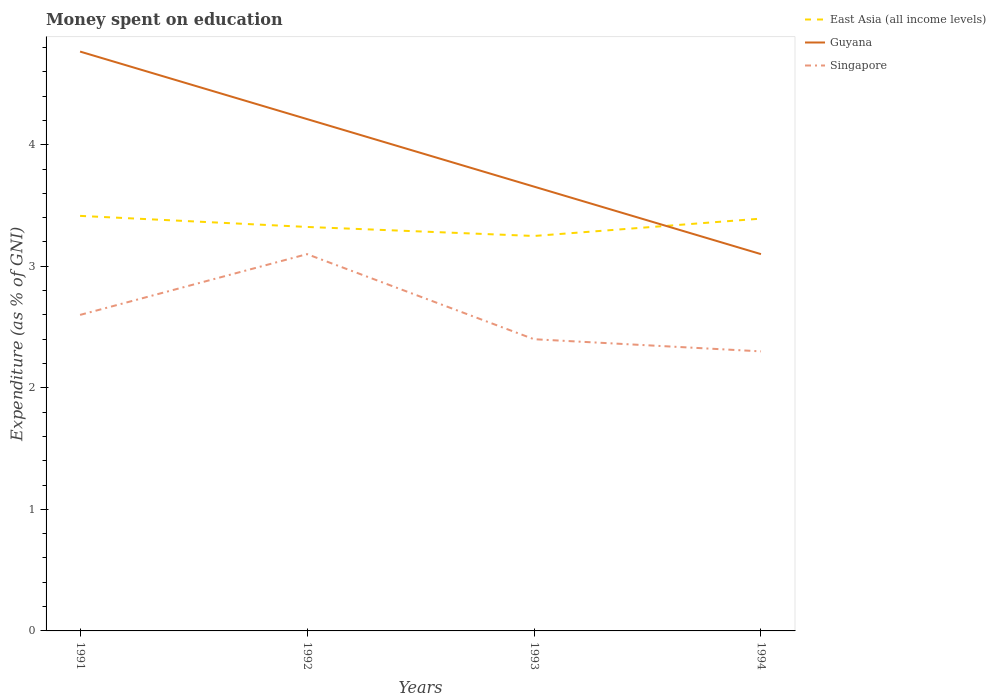Across all years, what is the maximum amount of money spent on education in East Asia (all income levels)?
Ensure brevity in your answer.  3.25. What is the total amount of money spent on education in Guyana in the graph?
Keep it short and to the point. 0.56. What is the difference between the highest and the second highest amount of money spent on education in East Asia (all income levels)?
Your answer should be very brief. 0.17. What is the difference between the highest and the lowest amount of money spent on education in Singapore?
Your answer should be compact. 2. How many lines are there?
Offer a very short reply. 3. How many years are there in the graph?
Give a very brief answer. 4. What is the difference between two consecutive major ticks on the Y-axis?
Provide a succinct answer. 1. Are the values on the major ticks of Y-axis written in scientific E-notation?
Keep it short and to the point. No. Does the graph contain any zero values?
Offer a very short reply. No. Does the graph contain grids?
Your answer should be compact. No. Where does the legend appear in the graph?
Provide a succinct answer. Top right. How many legend labels are there?
Your answer should be compact. 3. What is the title of the graph?
Provide a short and direct response. Money spent on education. Does "Afghanistan" appear as one of the legend labels in the graph?
Offer a very short reply. No. What is the label or title of the Y-axis?
Your response must be concise. Expenditure (as % of GNI). What is the Expenditure (as % of GNI) in East Asia (all income levels) in 1991?
Offer a terse response. 3.41. What is the Expenditure (as % of GNI) of Guyana in 1991?
Your answer should be very brief. 4.77. What is the Expenditure (as % of GNI) of East Asia (all income levels) in 1992?
Provide a succinct answer. 3.32. What is the Expenditure (as % of GNI) of Guyana in 1992?
Keep it short and to the point. 4.21. What is the Expenditure (as % of GNI) of Singapore in 1992?
Offer a very short reply. 3.1. What is the Expenditure (as % of GNI) in East Asia (all income levels) in 1993?
Your answer should be compact. 3.25. What is the Expenditure (as % of GNI) of Guyana in 1993?
Keep it short and to the point. 3.66. What is the Expenditure (as % of GNI) of East Asia (all income levels) in 1994?
Your response must be concise. 3.39. What is the Expenditure (as % of GNI) in Singapore in 1994?
Offer a terse response. 2.3. Across all years, what is the maximum Expenditure (as % of GNI) in East Asia (all income levels)?
Keep it short and to the point. 3.41. Across all years, what is the maximum Expenditure (as % of GNI) of Guyana?
Your response must be concise. 4.77. Across all years, what is the minimum Expenditure (as % of GNI) in East Asia (all income levels)?
Ensure brevity in your answer.  3.25. Across all years, what is the minimum Expenditure (as % of GNI) in Guyana?
Keep it short and to the point. 3.1. Across all years, what is the minimum Expenditure (as % of GNI) of Singapore?
Keep it short and to the point. 2.3. What is the total Expenditure (as % of GNI) in East Asia (all income levels) in the graph?
Provide a short and direct response. 13.38. What is the total Expenditure (as % of GNI) of Guyana in the graph?
Keep it short and to the point. 15.73. What is the difference between the Expenditure (as % of GNI) of East Asia (all income levels) in 1991 and that in 1992?
Your answer should be very brief. 0.09. What is the difference between the Expenditure (as % of GNI) in Guyana in 1991 and that in 1992?
Your answer should be compact. 0.56. What is the difference between the Expenditure (as % of GNI) in East Asia (all income levels) in 1991 and that in 1993?
Offer a very short reply. 0.17. What is the difference between the Expenditure (as % of GNI) of Guyana in 1991 and that in 1993?
Provide a succinct answer. 1.11. What is the difference between the Expenditure (as % of GNI) in Singapore in 1991 and that in 1993?
Provide a succinct answer. 0.2. What is the difference between the Expenditure (as % of GNI) in East Asia (all income levels) in 1991 and that in 1994?
Ensure brevity in your answer.  0.02. What is the difference between the Expenditure (as % of GNI) in East Asia (all income levels) in 1992 and that in 1993?
Ensure brevity in your answer.  0.07. What is the difference between the Expenditure (as % of GNI) in Guyana in 1992 and that in 1993?
Your answer should be very brief. 0.56. What is the difference between the Expenditure (as % of GNI) of Singapore in 1992 and that in 1993?
Offer a very short reply. 0.7. What is the difference between the Expenditure (as % of GNI) in East Asia (all income levels) in 1992 and that in 1994?
Offer a very short reply. -0.07. What is the difference between the Expenditure (as % of GNI) in East Asia (all income levels) in 1993 and that in 1994?
Your answer should be very brief. -0.14. What is the difference between the Expenditure (as % of GNI) in Guyana in 1993 and that in 1994?
Provide a short and direct response. 0.56. What is the difference between the Expenditure (as % of GNI) in Singapore in 1993 and that in 1994?
Offer a very short reply. 0.1. What is the difference between the Expenditure (as % of GNI) in East Asia (all income levels) in 1991 and the Expenditure (as % of GNI) in Guyana in 1992?
Provide a short and direct response. -0.8. What is the difference between the Expenditure (as % of GNI) of East Asia (all income levels) in 1991 and the Expenditure (as % of GNI) of Singapore in 1992?
Your response must be concise. 0.31. What is the difference between the Expenditure (as % of GNI) in East Asia (all income levels) in 1991 and the Expenditure (as % of GNI) in Guyana in 1993?
Ensure brevity in your answer.  -0.24. What is the difference between the Expenditure (as % of GNI) of East Asia (all income levels) in 1991 and the Expenditure (as % of GNI) of Singapore in 1993?
Keep it short and to the point. 1.01. What is the difference between the Expenditure (as % of GNI) in Guyana in 1991 and the Expenditure (as % of GNI) in Singapore in 1993?
Provide a succinct answer. 2.37. What is the difference between the Expenditure (as % of GNI) in East Asia (all income levels) in 1991 and the Expenditure (as % of GNI) in Guyana in 1994?
Offer a very short reply. 0.31. What is the difference between the Expenditure (as % of GNI) of East Asia (all income levels) in 1991 and the Expenditure (as % of GNI) of Singapore in 1994?
Keep it short and to the point. 1.11. What is the difference between the Expenditure (as % of GNI) of Guyana in 1991 and the Expenditure (as % of GNI) of Singapore in 1994?
Offer a very short reply. 2.47. What is the difference between the Expenditure (as % of GNI) of East Asia (all income levels) in 1992 and the Expenditure (as % of GNI) of Guyana in 1993?
Give a very brief answer. -0.33. What is the difference between the Expenditure (as % of GNI) of East Asia (all income levels) in 1992 and the Expenditure (as % of GNI) of Singapore in 1993?
Your answer should be compact. 0.92. What is the difference between the Expenditure (as % of GNI) in Guyana in 1992 and the Expenditure (as % of GNI) in Singapore in 1993?
Keep it short and to the point. 1.81. What is the difference between the Expenditure (as % of GNI) of East Asia (all income levels) in 1992 and the Expenditure (as % of GNI) of Guyana in 1994?
Offer a terse response. 0.22. What is the difference between the Expenditure (as % of GNI) of East Asia (all income levels) in 1992 and the Expenditure (as % of GNI) of Singapore in 1994?
Ensure brevity in your answer.  1.02. What is the difference between the Expenditure (as % of GNI) of Guyana in 1992 and the Expenditure (as % of GNI) of Singapore in 1994?
Your response must be concise. 1.91. What is the difference between the Expenditure (as % of GNI) in East Asia (all income levels) in 1993 and the Expenditure (as % of GNI) in Guyana in 1994?
Your answer should be very brief. 0.15. What is the difference between the Expenditure (as % of GNI) in East Asia (all income levels) in 1993 and the Expenditure (as % of GNI) in Singapore in 1994?
Your response must be concise. 0.95. What is the difference between the Expenditure (as % of GNI) of Guyana in 1993 and the Expenditure (as % of GNI) of Singapore in 1994?
Your answer should be compact. 1.36. What is the average Expenditure (as % of GNI) in East Asia (all income levels) per year?
Your response must be concise. 3.35. What is the average Expenditure (as % of GNI) of Guyana per year?
Give a very brief answer. 3.93. What is the average Expenditure (as % of GNI) in Singapore per year?
Keep it short and to the point. 2.6. In the year 1991, what is the difference between the Expenditure (as % of GNI) in East Asia (all income levels) and Expenditure (as % of GNI) in Guyana?
Ensure brevity in your answer.  -1.35. In the year 1991, what is the difference between the Expenditure (as % of GNI) of East Asia (all income levels) and Expenditure (as % of GNI) of Singapore?
Your answer should be compact. 0.81. In the year 1991, what is the difference between the Expenditure (as % of GNI) in Guyana and Expenditure (as % of GNI) in Singapore?
Your answer should be very brief. 2.17. In the year 1992, what is the difference between the Expenditure (as % of GNI) of East Asia (all income levels) and Expenditure (as % of GNI) of Guyana?
Ensure brevity in your answer.  -0.89. In the year 1992, what is the difference between the Expenditure (as % of GNI) of East Asia (all income levels) and Expenditure (as % of GNI) of Singapore?
Offer a very short reply. 0.22. In the year 1992, what is the difference between the Expenditure (as % of GNI) of Guyana and Expenditure (as % of GNI) of Singapore?
Make the answer very short. 1.11. In the year 1993, what is the difference between the Expenditure (as % of GNI) in East Asia (all income levels) and Expenditure (as % of GNI) in Guyana?
Your answer should be compact. -0.41. In the year 1993, what is the difference between the Expenditure (as % of GNI) in East Asia (all income levels) and Expenditure (as % of GNI) in Singapore?
Your response must be concise. 0.85. In the year 1993, what is the difference between the Expenditure (as % of GNI) of Guyana and Expenditure (as % of GNI) of Singapore?
Ensure brevity in your answer.  1.26. In the year 1994, what is the difference between the Expenditure (as % of GNI) of East Asia (all income levels) and Expenditure (as % of GNI) of Guyana?
Offer a terse response. 0.29. In the year 1994, what is the difference between the Expenditure (as % of GNI) of East Asia (all income levels) and Expenditure (as % of GNI) of Singapore?
Offer a very short reply. 1.09. In the year 1994, what is the difference between the Expenditure (as % of GNI) of Guyana and Expenditure (as % of GNI) of Singapore?
Your answer should be compact. 0.8. What is the ratio of the Expenditure (as % of GNI) in East Asia (all income levels) in 1991 to that in 1992?
Make the answer very short. 1.03. What is the ratio of the Expenditure (as % of GNI) of Guyana in 1991 to that in 1992?
Keep it short and to the point. 1.13. What is the ratio of the Expenditure (as % of GNI) of Singapore in 1991 to that in 1992?
Offer a very short reply. 0.84. What is the ratio of the Expenditure (as % of GNI) in East Asia (all income levels) in 1991 to that in 1993?
Give a very brief answer. 1.05. What is the ratio of the Expenditure (as % of GNI) in Guyana in 1991 to that in 1993?
Provide a short and direct response. 1.3. What is the ratio of the Expenditure (as % of GNI) of Singapore in 1991 to that in 1993?
Keep it short and to the point. 1.08. What is the ratio of the Expenditure (as % of GNI) of East Asia (all income levels) in 1991 to that in 1994?
Provide a short and direct response. 1.01. What is the ratio of the Expenditure (as % of GNI) of Guyana in 1991 to that in 1994?
Your answer should be very brief. 1.54. What is the ratio of the Expenditure (as % of GNI) in Singapore in 1991 to that in 1994?
Make the answer very short. 1.13. What is the ratio of the Expenditure (as % of GNI) in East Asia (all income levels) in 1992 to that in 1993?
Offer a terse response. 1.02. What is the ratio of the Expenditure (as % of GNI) in Guyana in 1992 to that in 1993?
Provide a short and direct response. 1.15. What is the ratio of the Expenditure (as % of GNI) of Singapore in 1992 to that in 1993?
Provide a succinct answer. 1.29. What is the ratio of the Expenditure (as % of GNI) of East Asia (all income levels) in 1992 to that in 1994?
Your answer should be compact. 0.98. What is the ratio of the Expenditure (as % of GNI) of Guyana in 1992 to that in 1994?
Your response must be concise. 1.36. What is the ratio of the Expenditure (as % of GNI) in Singapore in 1992 to that in 1994?
Ensure brevity in your answer.  1.35. What is the ratio of the Expenditure (as % of GNI) of East Asia (all income levels) in 1993 to that in 1994?
Ensure brevity in your answer.  0.96. What is the ratio of the Expenditure (as % of GNI) in Guyana in 1993 to that in 1994?
Your answer should be compact. 1.18. What is the ratio of the Expenditure (as % of GNI) in Singapore in 1993 to that in 1994?
Offer a terse response. 1.04. What is the difference between the highest and the second highest Expenditure (as % of GNI) of East Asia (all income levels)?
Offer a very short reply. 0.02. What is the difference between the highest and the second highest Expenditure (as % of GNI) in Guyana?
Keep it short and to the point. 0.56. What is the difference between the highest and the second highest Expenditure (as % of GNI) in Singapore?
Provide a succinct answer. 0.5. What is the difference between the highest and the lowest Expenditure (as % of GNI) in East Asia (all income levels)?
Keep it short and to the point. 0.17. What is the difference between the highest and the lowest Expenditure (as % of GNI) of Singapore?
Give a very brief answer. 0.8. 